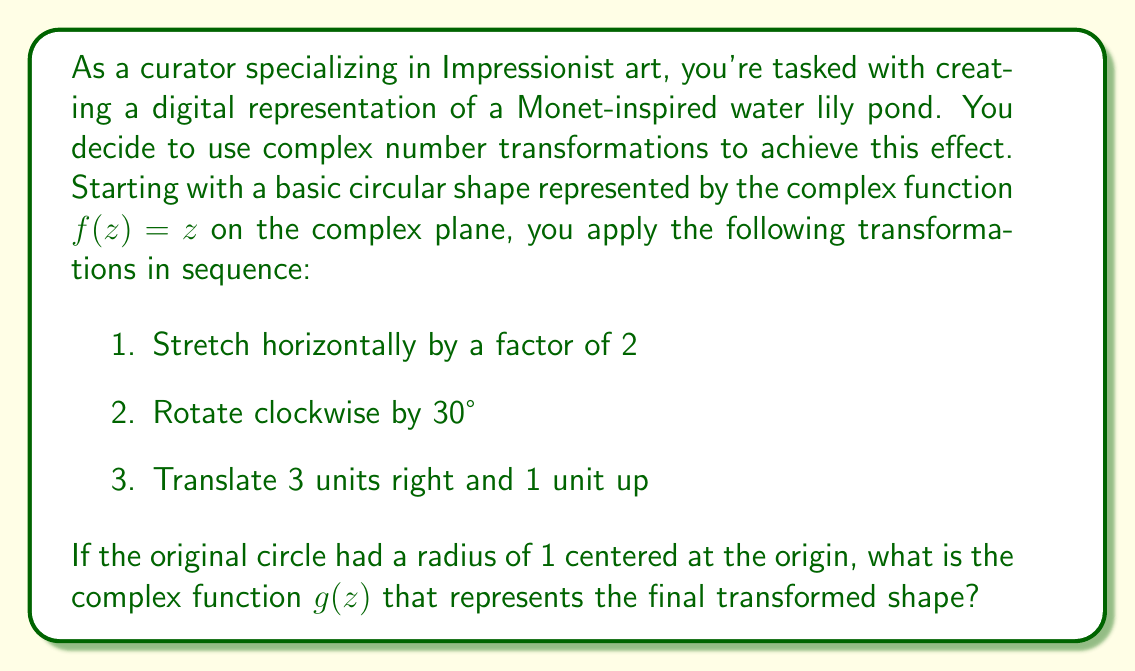Can you solve this math problem? Let's apply the transformations step by step:

1. Stretching horizontally by a factor of 2:
   This transformation is represented by $z \mapsto 2x + yi = (2 + i)z - iz$
   After this step, $f_1(z) = (2 + i)z - iz$

2. Rotating clockwise by 30°:
   Rotation by $\theta$ is achieved by multiplying by $e^{-i\theta}$
   For 30°, $\theta = \frac{\pi}{6}$
   $e^{-i\frac{\pi}{6}} = \cos(-\frac{\pi}{6}) + i\sin(-\frac{\pi}{6}) = \frac{\sqrt{3}}{2} - \frac{1}{2}i$
   After this step, $f_2(z) = (\frac{\sqrt{3}}{2} - \frac{1}{2}i)((2 + i)z - iz)$

3. Translating 3 units right and 1 unit up:
   This is achieved by adding the complex number $3 + i$
   The final function is $g(z) = (\frac{\sqrt{3}}{2} - \frac{1}{2}i)((2 + i)z - iz) + (3 + i)$

Simplifying:
$$\begin{align}
g(z) &= (\frac{\sqrt{3}}{2} - \frac{1}{2}i)((2 + i)z - iz) + (3 + i) \\
&= (\frac{\sqrt{3}}{2} - \frac{1}{2}i)(2z + iz - iz) + (3 + i) \\
&= (\frac{\sqrt{3}}{2} - \frac{1}{2}i)(2z) + (3 + i) \\
&= (\sqrt{3} - i)z + (3 + i)
\end{align}$$

Therefore, the final complex function representing the transformed shape is $g(z) = (\sqrt{3} - i)z + (3 + i)$.
Answer: $g(z) = (\sqrt{3} - i)z + (3 + i)$ 